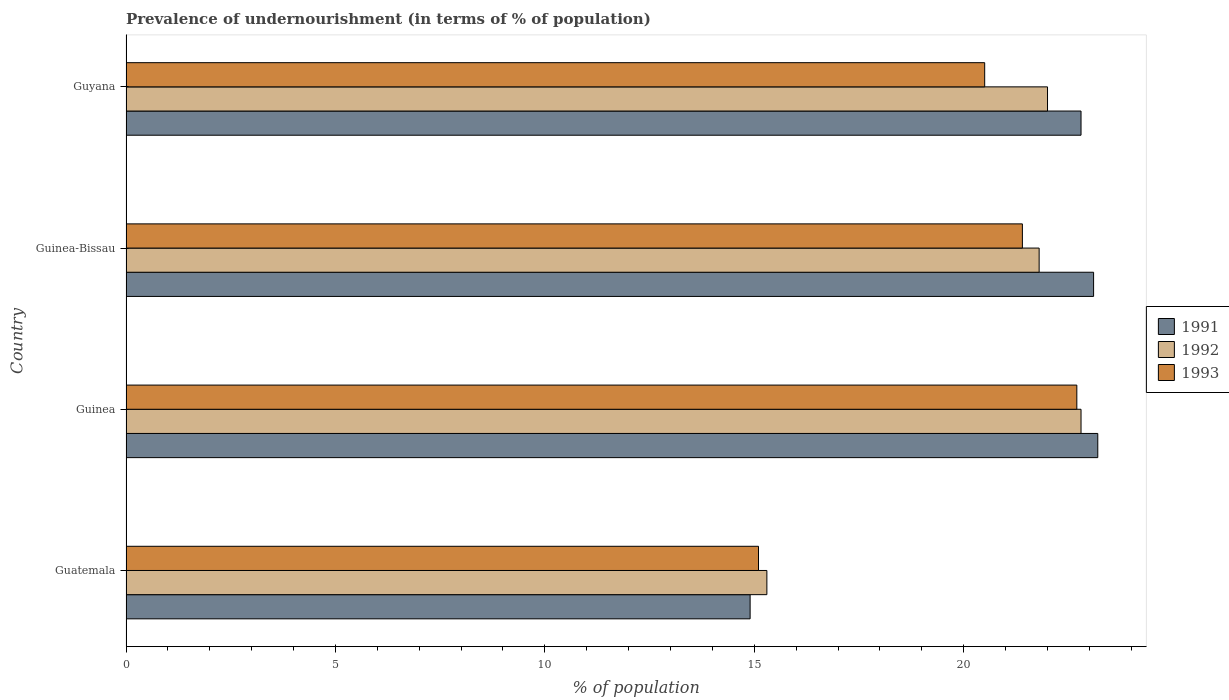How many groups of bars are there?
Your answer should be compact. 4. Are the number of bars per tick equal to the number of legend labels?
Provide a short and direct response. Yes. How many bars are there on the 4th tick from the top?
Provide a short and direct response. 3. How many bars are there on the 4th tick from the bottom?
Provide a succinct answer. 3. What is the label of the 3rd group of bars from the top?
Keep it short and to the point. Guinea. In how many cases, is the number of bars for a given country not equal to the number of legend labels?
Give a very brief answer. 0. What is the percentage of undernourished population in 1993 in Guyana?
Provide a succinct answer. 20.5. Across all countries, what is the maximum percentage of undernourished population in 1992?
Provide a short and direct response. 22.8. Across all countries, what is the minimum percentage of undernourished population in 1991?
Your answer should be compact. 14.9. In which country was the percentage of undernourished population in 1991 maximum?
Keep it short and to the point. Guinea. In which country was the percentage of undernourished population in 1992 minimum?
Provide a short and direct response. Guatemala. What is the total percentage of undernourished population in 1992 in the graph?
Keep it short and to the point. 81.9. What is the difference between the percentage of undernourished population in 1991 in Guinea and that in Guyana?
Keep it short and to the point. 0.4. What is the difference between the percentage of undernourished population in 1991 in Guyana and the percentage of undernourished population in 1992 in Guatemala?
Offer a very short reply. 7.5. What is the difference between the percentage of undernourished population in 1992 and percentage of undernourished population in 1993 in Guinea?
Provide a succinct answer. 0.1. What is the ratio of the percentage of undernourished population in 1992 in Guinea-Bissau to that in Guyana?
Provide a short and direct response. 0.99. Is the percentage of undernourished population in 1991 in Guinea less than that in Guyana?
Your answer should be very brief. No. What is the difference between the highest and the second highest percentage of undernourished population in 1993?
Provide a succinct answer. 1.3. In how many countries, is the percentage of undernourished population in 1993 greater than the average percentage of undernourished population in 1993 taken over all countries?
Offer a terse response. 3. What does the 1st bar from the top in Guyana represents?
Your answer should be compact. 1993. Is it the case that in every country, the sum of the percentage of undernourished population in 1991 and percentage of undernourished population in 1992 is greater than the percentage of undernourished population in 1993?
Keep it short and to the point. Yes. What is the difference between two consecutive major ticks on the X-axis?
Your answer should be compact. 5. Are the values on the major ticks of X-axis written in scientific E-notation?
Give a very brief answer. No. Where does the legend appear in the graph?
Your response must be concise. Center right. How are the legend labels stacked?
Make the answer very short. Vertical. What is the title of the graph?
Provide a succinct answer. Prevalence of undernourishment (in terms of % of population). Does "1978" appear as one of the legend labels in the graph?
Your answer should be compact. No. What is the label or title of the X-axis?
Offer a very short reply. % of population. What is the % of population of 1992 in Guatemala?
Offer a terse response. 15.3. What is the % of population of 1993 in Guatemala?
Your answer should be very brief. 15.1. What is the % of population in 1991 in Guinea?
Give a very brief answer. 23.2. What is the % of population in 1992 in Guinea?
Offer a very short reply. 22.8. What is the % of population of 1993 in Guinea?
Provide a short and direct response. 22.7. What is the % of population in 1991 in Guinea-Bissau?
Ensure brevity in your answer.  23.1. What is the % of population in 1992 in Guinea-Bissau?
Keep it short and to the point. 21.8. What is the % of population in 1993 in Guinea-Bissau?
Ensure brevity in your answer.  21.4. What is the % of population in 1991 in Guyana?
Your answer should be compact. 22.8. Across all countries, what is the maximum % of population of 1991?
Make the answer very short. 23.2. Across all countries, what is the maximum % of population in 1992?
Offer a very short reply. 22.8. Across all countries, what is the maximum % of population of 1993?
Your response must be concise. 22.7. Across all countries, what is the minimum % of population of 1992?
Your answer should be very brief. 15.3. What is the total % of population of 1992 in the graph?
Provide a succinct answer. 81.9. What is the total % of population of 1993 in the graph?
Provide a succinct answer. 79.7. What is the difference between the % of population of 1992 in Guatemala and that in Guinea?
Offer a terse response. -7.5. What is the difference between the % of population of 1993 in Guatemala and that in Guinea?
Keep it short and to the point. -7.6. What is the difference between the % of population of 1991 in Guatemala and that in Guyana?
Offer a very short reply. -7.9. What is the difference between the % of population in 1991 in Guinea and that in Guinea-Bissau?
Offer a very short reply. 0.1. What is the difference between the % of population of 1993 in Guinea and that in Guinea-Bissau?
Keep it short and to the point. 1.3. What is the difference between the % of population in 1991 in Guinea and that in Guyana?
Your answer should be compact. 0.4. What is the difference between the % of population in 1992 in Guinea-Bissau and that in Guyana?
Offer a terse response. -0.2. What is the difference between the % of population in 1991 in Guatemala and the % of population in 1992 in Guinea?
Your response must be concise. -7.9. What is the difference between the % of population of 1991 in Guatemala and the % of population of 1993 in Guinea?
Your answer should be very brief. -7.8. What is the difference between the % of population of 1991 in Guatemala and the % of population of 1992 in Guinea-Bissau?
Your answer should be compact. -6.9. What is the difference between the % of population of 1992 in Guatemala and the % of population of 1993 in Guinea-Bissau?
Your answer should be compact. -6.1. What is the difference between the % of population in 1991 in Guinea and the % of population in 1993 in Guinea-Bissau?
Your response must be concise. 1.8. What is the difference between the % of population of 1991 in Guinea and the % of population of 1993 in Guyana?
Provide a short and direct response. 2.7. What is the difference between the % of population in 1992 in Guinea and the % of population in 1993 in Guyana?
Your response must be concise. 2.3. What is the difference between the % of population in 1991 in Guinea-Bissau and the % of population in 1992 in Guyana?
Provide a short and direct response. 1.1. What is the average % of population of 1992 per country?
Ensure brevity in your answer.  20.48. What is the average % of population in 1993 per country?
Keep it short and to the point. 19.93. What is the difference between the % of population of 1992 and % of population of 1993 in Guatemala?
Ensure brevity in your answer.  0.2. What is the difference between the % of population of 1991 and % of population of 1993 in Guinea?
Your response must be concise. 0.5. What is the difference between the % of population in 1992 and % of population in 1993 in Guinea?
Give a very brief answer. 0.1. What is the difference between the % of population of 1991 and % of population of 1992 in Guinea-Bissau?
Keep it short and to the point. 1.3. What is the ratio of the % of population of 1991 in Guatemala to that in Guinea?
Ensure brevity in your answer.  0.64. What is the ratio of the % of population in 1992 in Guatemala to that in Guinea?
Ensure brevity in your answer.  0.67. What is the ratio of the % of population in 1993 in Guatemala to that in Guinea?
Offer a very short reply. 0.67. What is the ratio of the % of population in 1991 in Guatemala to that in Guinea-Bissau?
Keep it short and to the point. 0.65. What is the ratio of the % of population of 1992 in Guatemala to that in Guinea-Bissau?
Your answer should be very brief. 0.7. What is the ratio of the % of population of 1993 in Guatemala to that in Guinea-Bissau?
Your response must be concise. 0.71. What is the ratio of the % of population of 1991 in Guatemala to that in Guyana?
Make the answer very short. 0.65. What is the ratio of the % of population in 1992 in Guatemala to that in Guyana?
Provide a succinct answer. 0.7. What is the ratio of the % of population in 1993 in Guatemala to that in Guyana?
Offer a terse response. 0.74. What is the ratio of the % of population of 1991 in Guinea to that in Guinea-Bissau?
Your answer should be very brief. 1. What is the ratio of the % of population of 1992 in Guinea to that in Guinea-Bissau?
Your answer should be compact. 1.05. What is the ratio of the % of population of 1993 in Guinea to that in Guinea-Bissau?
Give a very brief answer. 1.06. What is the ratio of the % of population in 1991 in Guinea to that in Guyana?
Your answer should be compact. 1.02. What is the ratio of the % of population of 1992 in Guinea to that in Guyana?
Make the answer very short. 1.04. What is the ratio of the % of population of 1993 in Guinea to that in Guyana?
Your answer should be very brief. 1.11. What is the ratio of the % of population in 1991 in Guinea-Bissau to that in Guyana?
Ensure brevity in your answer.  1.01. What is the ratio of the % of population of 1992 in Guinea-Bissau to that in Guyana?
Offer a very short reply. 0.99. What is the ratio of the % of population in 1993 in Guinea-Bissau to that in Guyana?
Offer a terse response. 1.04. What is the difference between the highest and the second highest % of population of 1992?
Give a very brief answer. 0.8. What is the difference between the highest and the second highest % of population in 1993?
Provide a succinct answer. 1.3. 